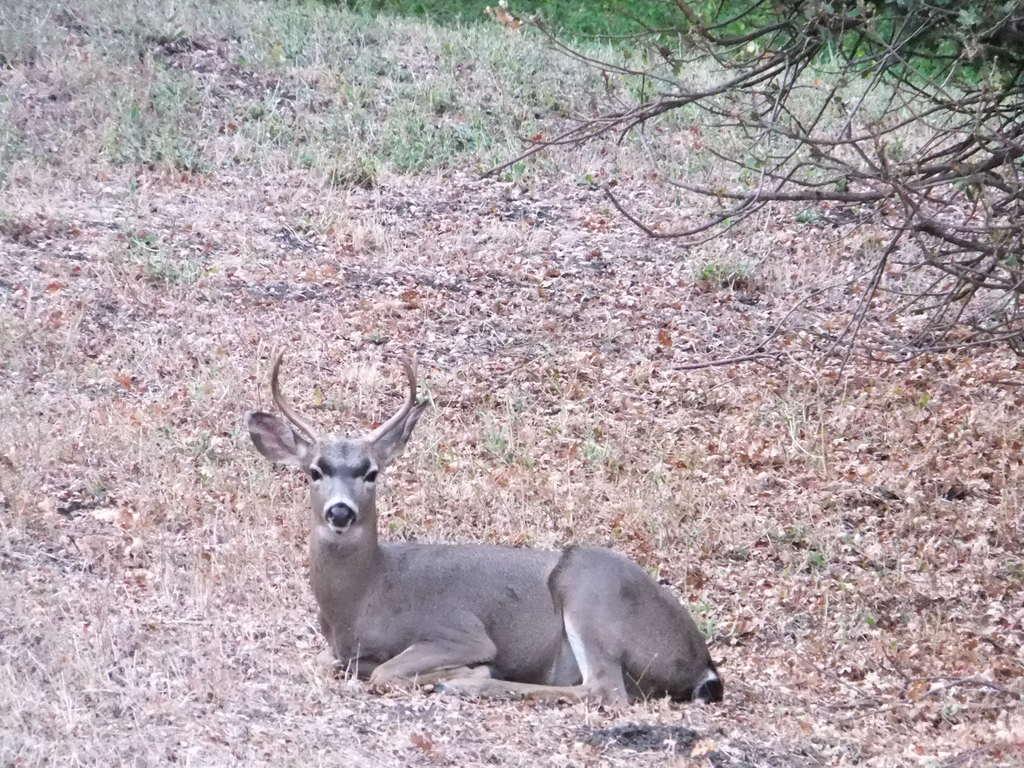Could you give a brief overview of what you see in this image? In this image in the front there is an animal sitting on the ground. In the background there is grass on the ground and there are dry trees. 